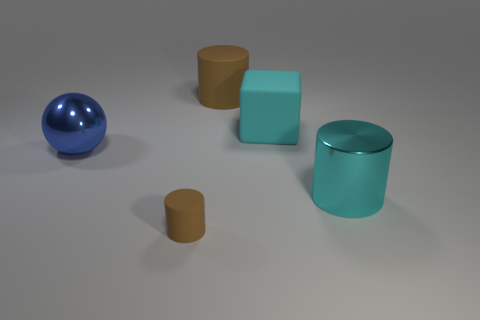Add 2 tiny matte cubes. How many objects exist? 7 Subtract all balls. How many objects are left? 4 Add 4 big metallic spheres. How many big metallic spheres are left? 5 Add 2 big red rubber spheres. How many big red rubber spheres exist? 2 Subtract 1 blue balls. How many objects are left? 4 Subtract all cyan things. Subtract all metal cylinders. How many objects are left? 2 